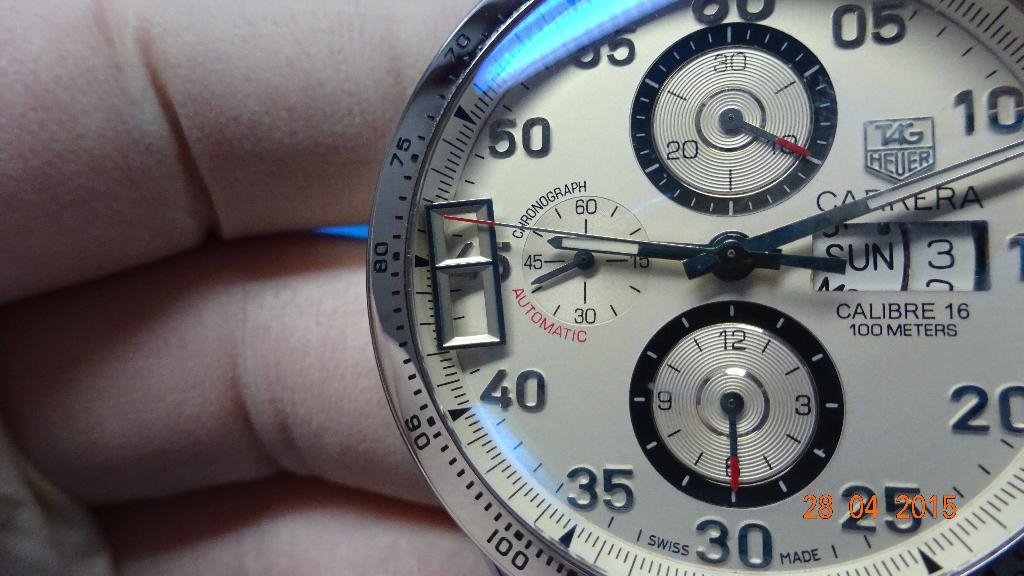What day of the week is shown on this watch?
Offer a very short reply. Sunday. What year is it?
Ensure brevity in your answer.  2015. 